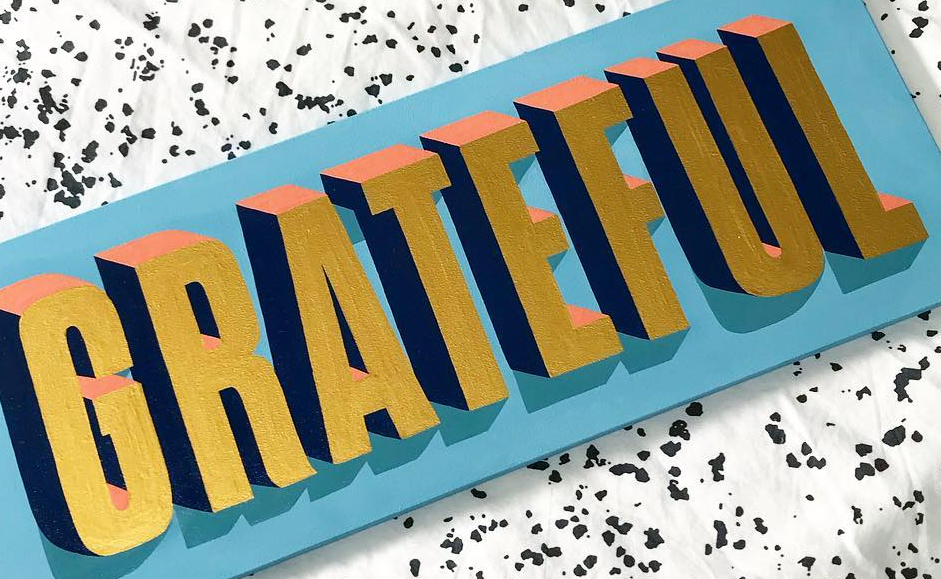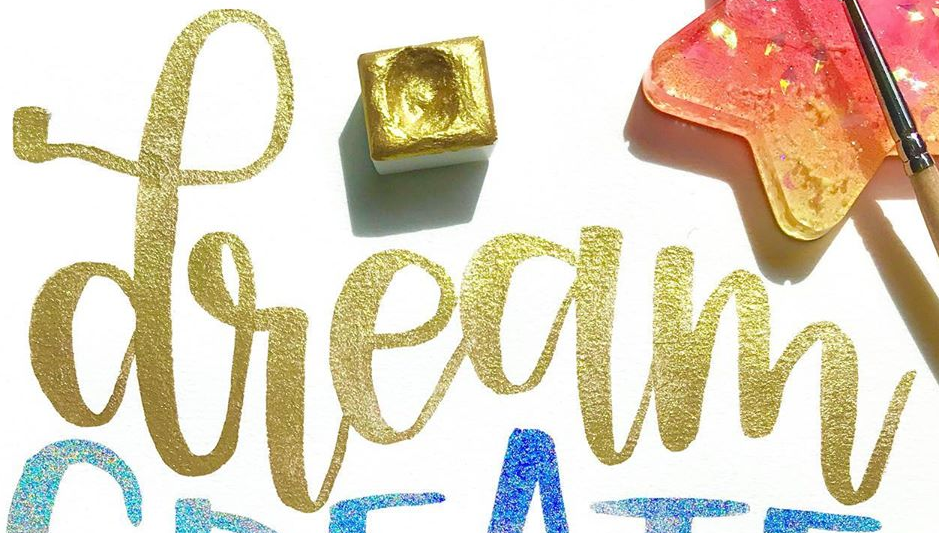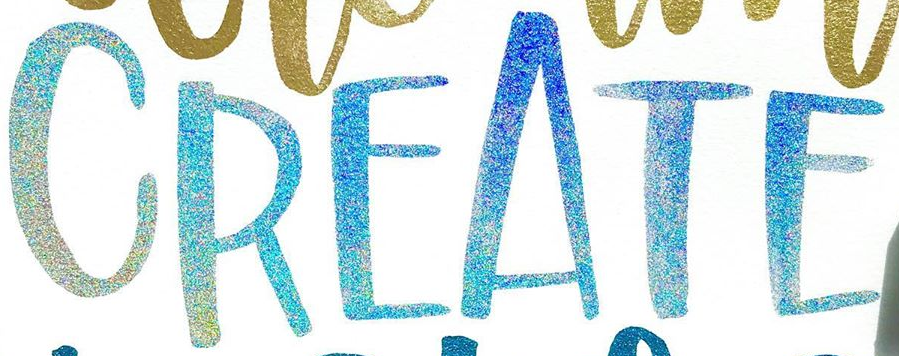Transcribe the words shown in these images in order, separated by a semicolon. GRATEFUL; dream; CREATE 